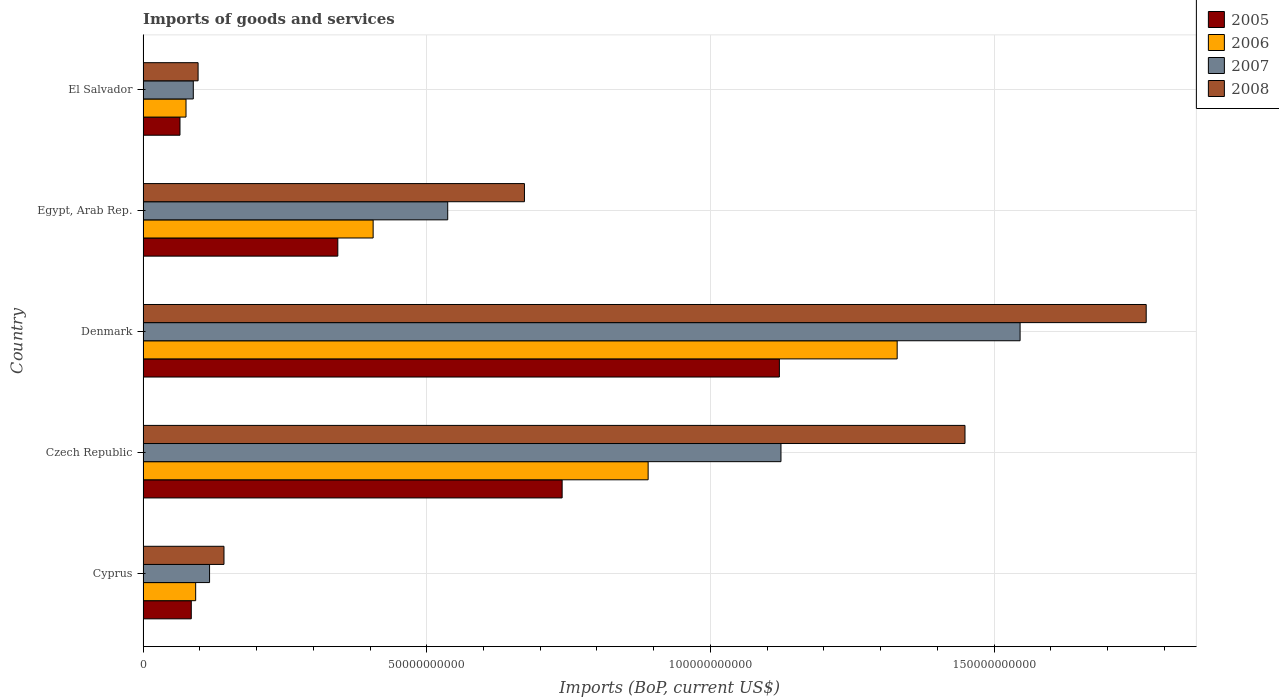How many different coloured bars are there?
Your answer should be compact. 4. How many groups of bars are there?
Your answer should be compact. 5. Are the number of bars on each tick of the Y-axis equal?
Offer a very short reply. Yes. How many bars are there on the 5th tick from the bottom?
Ensure brevity in your answer.  4. What is the label of the 1st group of bars from the top?
Keep it short and to the point. El Salvador. What is the amount spent on imports in 2007 in Egypt, Arab Rep.?
Keep it short and to the point. 5.37e+1. Across all countries, what is the maximum amount spent on imports in 2006?
Ensure brevity in your answer.  1.33e+11. Across all countries, what is the minimum amount spent on imports in 2008?
Give a very brief answer. 9.70e+09. In which country was the amount spent on imports in 2005 maximum?
Offer a very short reply. Denmark. In which country was the amount spent on imports in 2007 minimum?
Provide a succinct answer. El Salvador. What is the total amount spent on imports in 2007 in the graph?
Your response must be concise. 3.41e+11. What is the difference between the amount spent on imports in 2006 in Cyprus and that in Egypt, Arab Rep.?
Provide a succinct answer. -3.13e+1. What is the difference between the amount spent on imports in 2008 in Egypt, Arab Rep. and the amount spent on imports in 2007 in Czech Republic?
Offer a terse response. -4.52e+1. What is the average amount spent on imports in 2008 per country?
Offer a very short reply. 8.26e+1. What is the difference between the amount spent on imports in 2006 and amount spent on imports in 2005 in Egypt, Arab Rep.?
Your response must be concise. 6.23e+09. In how many countries, is the amount spent on imports in 2007 greater than 110000000000 US$?
Your answer should be compact. 2. What is the ratio of the amount spent on imports in 2006 in Czech Republic to that in Egypt, Arab Rep.?
Your answer should be compact. 2.2. Is the amount spent on imports in 2007 in Czech Republic less than that in Egypt, Arab Rep.?
Give a very brief answer. No. What is the difference between the highest and the second highest amount spent on imports in 2007?
Make the answer very short. 4.21e+1. What is the difference between the highest and the lowest amount spent on imports in 2007?
Your answer should be very brief. 1.46e+11. Is the sum of the amount spent on imports in 2005 in Cyprus and Czech Republic greater than the maximum amount spent on imports in 2007 across all countries?
Your answer should be very brief. No. What does the 2nd bar from the bottom in El Salvador represents?
Provide a succinct answer. 2006. Is it the case that in every country, the sum of the amount spent on imports in 2005 and amount spent on imports in 2008 is greater than the amount spent on imports in 2006?
Make the answer very short. Yes. How many bars are there?
Offer a very short reply. 20. Does the graph contain any zero values?
Keep it short and to the point. No. Does the graph contain grids?
Your answer should be very brief. Yes. Where does the legend appear in the graph?
Provide a succinct answer. Top right. What is the title of the graph?
Offer a very short reply. Imports of goods and services. What is the label or title of the X-axis?
Your answer should be very brief. Imports (BoP, current US$). What is the Imports (BoP, current US$) in 2005 in Cyprus?
Offer a terse response. 8.50e+09. What is the Imports (BoP, current US$) in 2006 in Cyprus?
Ensure brevity in your answer.  9.27e+09. What is the Imports (BoP, current US$) of 2007 in Cyprus?
Your answer should be compact. 1.17e+1. What is the Imports (BoP, current US$) of 2008 in Cyprus?
Provide a short and direct response. 1.43e+1. What is the Imports (BoP, current US$) in 2005 in Czech Republic?
Provide a short and direct response. 7.39e+1. What is the Imports (BoP, current US$) of 2006 in Czech Republic?
Give a very brief answer. 8.90e+1. What is the Imports (BoP, current US$) of 2007 in Czech Republic?
Ensure brevity in your answer.  1.12e+11. What is the Imports (BoP, current US$) of 2008 in Czech Republic?
Give a very brief answer. 1.45e+11. What is the Imports (BoP, current US$) in 2005 in Denmark?
Your answer should be very brief. 1.12e+11. What is the Imports (BoP, current US$) of 2006 in Denmark?
Offer a terse response. 1.33e+11. What is the Imports (BoP, current US$) in 2007 in Denmark?
Your answer should be compact. 1.55e+11. What is the Imports (BoP, current US$) of 2008 in Denmark?
Give a very brief answer. 1.77e+11. What is the Imports (BoP, current US$) in 2005 in Egypt, Arab Rep.?
Ensure brevity in your answer.  3.43e+1. What is the Imports (BoP, current US$) of 2006 in Egypt, Arab Rep.?
Provide a short and direct response. 4.06e+1. What is the Imports (BoP, current US$) of 2007 in Egypt, Arab Rep.?
Ensure brevity in your answer.  5.37e+1. What is the Imports (BoP, current US$) of 2008 in Egypt, Arab Rep.?
Keep it short and to the point. 6.72e+1. What is the Imports (BoP, current US$) of 2005 in El Salvador?
Your response must be concise. 6.51e+09. What is the Imports (BoP, current US$) of 2006 in El Salvador?
Make the answer very short. 7.57e+09. What is the Imports (BoP, current US$) of 2007 in El Salvador?
Your response must be concise. 8.86e+09. What is the Imports (BoP, current US$) of 2008 in El Salvador?
Offer a very short reply. 9.70e+09. Across all countries, what is the maximum Imports (BoP, current US$) in 2005?
Your answer should be very brief. 1.12e+11. Across all countries, what is the maximum Imports (BoP, current US$) of 2006?
Your response must be concise. 1.33e+11. Across all countries, what is the maximum Imports (BoP, current US$) in 2007?
Give a very brief answer. 1.55e+11. Across all countries, what is the maximum Imports (BoP, current US$) of 2008?
Keep it short and to the point. 1.77e+11. Across all countries, what is the minimum Imports (BoP, current US$) in 2005?
Your response must be concise. 6.51e+09. Across all countries, what is the minimum Imports (BoP, current US$) in 2006?
Offer a very short reply. 7.57e+09. Across all countries, what is the minimum Imports (BoP, current US$) of 2007?
Provide a short and direct response. 8.86e+09. Across all countries, what is the minimum Imports (BoP, current US$) of 2008?
Offer a terse response. 9.70e+09. What is the total Imports (BoP, current US$) in 2005 in the graph?
Give a very brief answer. 2.35e+11. What is the total Imports (BoP, current US$) in 2006 in the graph?
Offer a terse response. 2.79e+11. What is the total Imports (BoP, current US$) of 2007 in the graph?
Keep it short and to the point. 3.41e+11. What is the total Imports (BoP, current US$) in 2008 in the graph?
Offer a terse response. 4.13e+11. What is the difference between the Imports (BoP, current US$) of 2005 in Cyprus and that in Czech Republic?
Your response must be concise. -6.54e+1. What is the difference between the Imports (BoP, current US$) in 2006 in Cyprus and that in Czech Republic?
Offer a terse response. -7.97e+1. What is the difference between the Imports (BoP, current US$) of 2007 in Cyprus and that in Czech Republic?
Keep it short and to the point. -1.01e+11. What is the difference between the Imports (BoP, current US$) in 2008 in Cyprus and that in Czech Republic?
Keep it short and to the point. -1.31e+11. What is the difference between the Imports (BoP, current US$) in 2005 in Cyprus and that in Denmark?
Your response must be concise. -1.04e+11. What is the difference between the Imports (BoP, current US$) in 2006 in Cyprus and that in Denmark?
Ensure brevity in your answer.  -1.24e+11. What is the difference between the Imports (BoP, current US$) in 2007 in Cyprus and that in Denmark?
Your answer should be very brief. -1.43e+11. What is the difference between the Imports (BoP, current US$) in 2008 in Cyprus and that in Denmark?
Offer a very short reply. -1.63e+11. What is the difference between the Imports (BoP, current US$) of 2005 in Cyprus and that in Egypt, Arab Rep.?
Your answer should be very brief. -2.58e+1. What is the difference between the Imports (BoP, current US$) in 2006 in Cyprus and that in Egypt, Arab Rep.?
Your response must be concise. -3.13e+1. What is the difference between the Imports (BoP, current US$) in 2007 in Cyprus and that in Egypt, Arab Rep.?
Provide a short and direct response. -4.20e+1. What is the difference between the Imports (BoP, current US$) in 2008 in Cyprus and that in Egypt, Arab Rep.?
Provide a succinct answer. -5.30e+1. What is the difference between the Imports (BoP, current US$) in 2005 in Cyprus and that in El Salvador?
Provide a succinct answer. 1.99e+09. What is the difference between the Imports (BoP, current US$) in 2006 in Cyprus and that in El Salvador?
Your answer should be very brief. 1.70e+09. What is the difference between the Imports (BoP, current US$) of 2007 in Cyprus and that in El Salvador?
Offer a very short reply. 2.87e+09. What is the difference between the Imports (BoP, current US$) in 2008 in Cyprus and that in El Salvador?
Your answer should be compact. 4.56e+09. What is the difference between the Imports (BoP, current US$) of 2005 in Czech Republic and that in Denmark?
Your answer should be very brief. -3.83e+1. What is the difference between the Imports (BoP, current US$) in 2006 in Czech Republic and that in Denmark?
Your answer should be very brief. -4.39e+1. What is the difference between the Imports (BoP, current US$) in 2007 in Czech Republic and that in Denmark?
Offer a very short reply. -4.21e+1. What is the difference between the Imports (BoP, current US$) of 2008 in Czech Republic and that in Denmark?
Give a very brief answer. -3.19e+1. What is the difference between the Imports (BoP, current US$) in 2005 in Czech Republic and that in Egypt, Arab Rep.?
Make the answer very short. 3.95e+1. What is the difference between the Imports (BoP, current US$) in 2006 in Czech Republic and that in Egypt, Arab Rep.?
Ensure brevity in your answer.  4.85e+1. What is the difference between the Imports (BoP, current US$) of 2007 in Czech Republic and that in Egypt, Arab Rep.?
Offer a very short reply. 5.87e+1. What is the difference between the Imports (BoP, current US$) of 2008 in Czech Republic and that in Egypt, Arab Rep.?
Give a very brief answer. 7.76e+1. What is the difference between the Imports (BoP, current US$) in 2005 in Czech Republic and that in El Salvador?
Provide a short and direct response. 6.74e+1. What is the difference between the Imports (BoP, current US$) of 2006 in Czech Republic and that in El Salvador?
Your answer should be compact. 8.15e+1. What is the difference between the Imports (BoP, current US$) in 2007 in Czech Republic and that in El Salvador?
Offer a terse response. 1.04e+11. What is the difference between the Imports (BoP, current US$) in 2008 in Czech Republic and that in El Salvador?
Your answer should be very brief. 1.35e+11. What is the difference between the Imports (BoP, current US$) of 2005 in Denmark and that in Egypt, Arab Rep.?
Ensure brevity in your answer.  7.78e+1. What is the difference between the Imports (BoP, current US$) of 2006 in Denmark and that in Egypt, Arab Rep.?
Keep it short and to the point. 9.24e+1. What is the difference between the Imports (BoP, current US$) in 2007 in Denmark and that in Egypt, Arab Rep.?
Offer a terse response. 1.01e+11. What is the difference between the Imports (BoP, current US$) in 2008 in Denmark and that in Egypt, Arab Rep.?
Provide a succinct answer. 1.10e+11. What is the difference between the Imports (BoP, current US$) of 2005 in Denmark and that in El Salvador?
Offer a terse response. 1.06e+11. What is the difference between the Imports (BoP, current US$) of 2006 in Denmark and that in El Salvador?
Offer a terse response. 1.25e+11. What is the difference between the Imports (BoP, current US$) in 2007 in Denmark and that in El Salvador?
Your answer should be compact. 1.46e+11. What is the difference between the Imports (BoP, current US$) of 2008 in Denmark and that in El Salvador?
Offer a terse response. 1.67e+11. What is the difference between the Imports (BoP, current US$) in 2005 in Egypt, Arab Rep. and that in El Salvador?
Make the answer very short. 2.78e+1. What is the difference between the Imports (BoP, current US$) in 2006 in Egypt, Arab Rep. and that in El Salvador?
Provide a short and direct response. 3.30e+1. What is the difference between the Imports (BoP, current US$) in 2007 in Egypt, Arab Rep. and that in El Salvador?
Keep it short and to the point. 4.48e+1. What is the difference between the Imports (BoP, current US$) of 2008 in Egypt, Arab Rep. and that in El Salvador?
Give a very brief answer. 5.75e+1. What is the difference between the Imports (BoP, current US$) of 2005 in Cyprus and the Imports (BoP, current US$) of 2006 in Czech Republic?
Your response must be concise. -8.05e+1. What is the difference between the Imports (BoP, current US$) in 2005 in Cyprus and the Imports (BoP, current US$) in 2007 in Czech Republic?
Make the answer very short. -1.04e+11. What is the difference between the Imports (BoP, current US$) in 2005 in Cyprus and the Imports (BoP, current US$) in 2008 in Czech Republic?
Your response must be concise. -1.36e+11. What is the difference between the Imports (BoP, current US$) in 2006 in Cyprus and the Imports (BoP, current US$) in 2007 in Czech Republic?
Your answer should be very brief. -1.03e+11. What is the difference between the Imports (BoP, current US$) in 2006 in Cyprus and the Imports (BoP, current US$) in 2008 in Czech Republic?
Offer a terse response. -1.36e+11. What is the difference between the Imports (BoP, current US$) of 2007 in Cyprus and the Imports (BoP, current US$) of 2008 in Czech Republic?
Keep it short and to the point. -1.33e+11. What is the difference between the Imports (BoP, current US$) in 2005 in Cyprus and the Imports (BoP, current US$) in 2006 in Denmark?
Make the answer very short. -1.24e+11. What is the difference between the Imports (BoP, current US$) in 2005 in Cyprus and the Imports (BoP, current US$) in 2007 in Denmark?
Ensure brevity in your answer.  -1.46e+11. What is the difference between the Imports (BoP, current US$) in 2005 in Cyprus and the Imports (BoP, current US$) in 2008 in Denmark?
Offer a very short reply. -1.68e+11. What is the difference between the Imports (BoP, current US$) of 2006 in Cyprus and the Imports (BoP, current US$) of 2007 in Denmark?
Ensure brevity in your answer.  -1.45e+11. What is the difference between the Imports (BoP, current US$) of 2006 in Cyprus and the Imports (BoP, current US$) of 2008 in Denmark?
Give a very brief answer. -1.68e+11. What is the difference between the Imports (BoP, current US$) in 2007 in Cyprus and the Imports (BoP, current US$) in 2008 in Denmark?
Keep it short and to the point. -1.65e+11. What is the difference between the Imports (BoP, current US$) of 2005 in Cyprus and the Imports (BoP, current US$) of 2006 in Egypt, Arab Rep.?
Offer a very short reply. -3.21e+1. What is the difference between the Imports (BoP, current US$) in 2005 in Cyprus and the Imports (BoP, current US$) in 2007 in Egypt, Arab Rep.?
Offer a very short reply. -4.52e+1. What is the difference between the Imports (BoP, current US$) in 2005 in Cyprus and the Imports (BoP, current US$) in 2008 in Egypt, Arab Rep.?
Keep it short and to the point. -5.87e+1. What is the difference between the Imports (BoP, current US$) of 2006 in Cyprus and the Imports (BoP, current US$) of 2007 in Egypt, Arab Rep.?
Ensure brevity in your answer.  -4.44e+1. What is the difference between the Imports (BoP, current US$) of 2006 in Cyprus and the Imports (BoP, current US$) of 2008 in Egypt, Arab Rep.?
Your answer should be very brief. -5.79e+1. What is the difference between the Imports (BoP, current US$) in 2007 in Cyprus and the Imports (BoP, current US$) in 2008 in Egypt, Arab Rep.?
Your answer should be very brief. -5.55e+1. What is the difference between the Imports (BoP, current US$) in 2005 in Cyprus and the Imports (BoP, current US$) in 2006 in El Salvador?
Make the answer very short. 9.27e+08. What is the difference between the Imports (BoP, current US$) in 2005 in Cyprus and the Imports (BoP, current US$) in 2007 in El Salvador?
Give a very brief answer. -3.57e+08. What is the difference between the Imports (BoP, current US$) of 2005 in Cyprus and the Imports (BoP, current US$) of 2008 in El Salvador?
Provide a succinct answer. -1.20e+09. What is the difference between the Imports (BoP, current US$) of 2006 in Cyprus and the Imports (BoP, current US$) of 2007 in El Salvador?
Offer a very short reply. 4.18e+08. What is the difference between the Imports (BoP, current US$) of 2006 in Cyprus and the Imports (BoP, current US$) of 2008 in El Salvador?
Provide a short and direct response. -4.26e+08. What is the difference between the Imports (BoP, current US$) in 2007 in Cyprus and the Imports (BoP, current US$) in 2008 in El Salvador?
Offer a terse response. 2.02e+09. What is the difference between the Imports (BoP, current US$) in 2005 in Czech Republic and the Imports (BoP, current US$) in 2006 in Denmark?
Provide a short and direct response. -5.91e+1. What is the difference between the Imports (BoP, current US$) in 2005 in Czech Republic and the Imports (BoP, current US$) in 2007 in Denmark?
Ensure brevity in your answer.  -8.07e+1. What is the difference between the Imports (BoP, current US$) of 2005 in Czech Republic and the Imports (BoP, current US$) of 2008 in Denmark?
Offer a terse response. -1.03e+11. What is the difference between the Imports (BoP, current US$) in 2006 in Czech Republic and the Imports (BoP, current US$) in 2007 in Denmark?
Offer a very short reply. -6.56e+1. What is the difference between the Imports (BoP, current US$) in 2006 in Czech Republic and the Imports (BoP, current US$) in 2008 in Denmark?
Your answer should be very brief. -8.78e+1. What is the difference between the Imports (BoP, current US$) in 2007 in Czech Republic and the Imports (BoP, current US$) in 2008 in Denmark?
Give a very brief answer. -6.44e+1. What is the difference between the Imports (BoP, current US$) in 2005 in Czech Republic and the Imports (BoP, current US$) in 2006 in Egypt, Arab Rep.?
Provide a short and direct response. 3.33e+1. What is the difference between the Imports (BoP, current US$) in 2005 in Czech Republic and the Imports (BoP, current US$) in 2007 in Egypt, Arab Rep.?
Ensure brevity in your answer.  2.02e+1. What is the difference between the Imports (BoP, current US$) of 2005 in Czech Republic and the Imports (BoP, current US$) of 2008 in Egypt, Arab Rep.?
Provide a succinct answer. 6.64e+09. What is the difference between the Imports (BoP, current US$) in 2006 in Czech Republic and the Imports (BoP, current US$) in 2007 in Egypt, Arab Rep.?
Your answer should be very brief. 3.53e+1. What is the difference between the Imports (BoP, current US$) of 2006 in Czech Republic and the Imports (BoP, current US$) of 2008 in Egypt, Arab Rep.?
Make the answer very short. 2.18e+1. What is the difference between the Imports (BoP, current US$) of 2007 in Czech Republic and the Imports (BoP, current US$) of 2008 in Egypt, Arab Rep.?
Provide a succinct answer. 4.52e+1. What is the difference between the Imports (BoP, current US$) in 2005 in Czech Republic and the Imports (BoP, current US$) in 2006 in El Salvador?
Provide a short and direct response. 6.63e+1. What is the difference between the Imports (BoP, current US$) in 2005 in Czech Republic and the Imports (BoP, current US$) in 2007 in El Salvador?
Your response must be concise. 6.50e+1. What is the difference between the Imports (BoP, current US$) in 2005 in Czech Republic and the Imports (BoP, current US$) in 2008 in El Salvador?
Keep it short and to the point. 6.42e+1. What is the difference between the Imports (BoP, current US$) of 2006 in Czech Republic and the Imports (BoP, current US$) of 2007 in El Salvador?
Your answer should be compact. 8.02e+1. What is the difference between the Imports (BoP, current US$) in 2006 in Czech Republic and the Imports (BoP, current US$) in 2008 in El Salvador?
Offer a very short reply. 7.93e+1. What is the difference between the Imports (BoP, current US$) of 2007 in Czech Republic and the Imports (BoP, current US$) of 2008 in El Salvador?
Give a very brief answer. 1.03e+11. What is the difference between the Imports (BoP, current US$) of 2005 in Denmark and the Imports (BoP, current US$) of 2006 in Egypt, Arab Rep.?
Your response must be concise. 7.16e+1. What is the difference between the Imports (BoP, current US$) of 2005 in Denmark and the Imports (BoP, current US$) of 2007 in Egypt, Arab Rep.?
Offer a terse response. 5.85e+1. What is the difference between the Imports (BoP, current US$) of 2005 in Denmark and the Imports (BoP, current US$) of 2008 in Egypt, Arab Rep.?
Your answer should be very brief. 4.49e+1. What is the difference between the Imports (BoP, current US$) of 2006 in Denmark and the Imports (BoP, current US$) of 2007 in Egypt, Arab Rep.?
Offer a very short reply. 7.92e+1. What is the difference between the Imports (BoP, current US$) of 2006 in Denmark and the Imports (BoP, current US$) of 2008 in Egypt, Arab Rep.?
Your response must be concise. 6.57e+1. What is the difference between the Imports (BoP, current US$) of 2007 in Denmark and the Imports (BoP, current US$) of 2008 in Egypt, Arab Rep.?
Your answer should be compact. 8.74e+1. What is the difference between the Imports (BoP, current US$) in 2005 in Denmark and the Imports (BoP, current US$) in 2006 in El Salvador?
Provide a short and direct response. 1.05e+11. What is the difference between the Imports (BoP, current US$) in 2005 in Denmark and the Imports (BoP, current US$) in 2007 in El Salvador?
Provide a succinct answer. 1.03e+11. What is the difference between the Imports (BoP, current US$) of 2005 in Denmark and the Imports (BoP, current US$) of 2008 in El Salvador?
Provide a succinct answer. 1.02e+11. What is the difference between the Imports (BoP, current US$) of 2006 in Denmark and the Imports (BoP, current US$) of 2007 in El Salvador?
Offer a terse response. 1.24e+11. What is the difference between the Imports (BoP, current US$) in 2006 in Denmark and the Imports (BoP, current US$) in 2008 in El Salvador?
Make the answer very short. 1.23e+11. What is the difference between the Imports (BoP, current US$) of 2007 in Denmark and the Imports (BoP, current US$) of 2008 in El Salvador?
Keep it short and to the point. 1.45e+11. What is the difference between the Imports (BoP, current US$) of 2005 in Egypt, Arab Rep. and the Imports (BoP, current US$) of 2006 in El Salvador?
Provide a short and direct response. 2.68e+1. What is the difference between the Imports (BoP, current US$) in 2005 in Egypt, Arab Rep. and the Imports (BoP, current US$) in 2007 in El Salvador?
Make the answer very short. 2.55e+1. What is the difference between the Imports (BoP, current US$) in 2005 in Egypt, Arab Rep. and the Imports (BoP, current US$) in 2008 in El Salvador?
Offer a terse response. 2.46e+1. What is the difference between the Imports (BoP, current US$) of 2006 in Egypt, Arab Rep. and the Imports (BoP, current US$) of 2007 in El Salvador?
Provide a succinct answer. 3.17e+1. What is the difference between the Imports (BoP, current US$) in 2006 in Egypt, Arab Rep. and the Imports (BoP, current US$) in 2008 in El Salvador?
Ensure brevity in your answer.  3.09e+1. What is the difference between the Imports (BoP, current US$) in 2007 in Egypt, Arab Rep. and the Imports (BoP, current US$) in 2008 in El Salvador?
Make the answer very short. 4.40e+1. What is the average Imports (BoP, current US$) of 2005 per country?
Give a very brief answer. 4.71e+1. What is the average Imports (BoP, current US$) of 2006 per country?
Keep it short and to the point. 5.59e+1. What is the average Imports (BoP, current US$) in 2007 per country?
Offer a very short reply. 6.83e+1. What is the average Imports (BoP, current US$) in 2008 per country?
Keep it short and to the point. 8.26e+1. What is the difference between the Imports (BoP, current US$) of 2005 and Imports (BoP, current US$) of 2006 in Cyprus?
Give a very brief answer. -7.76e+08. What is the difference between the Imports (BoP, current US$) in 2005 and Imports (BoP, current US$) in 2007 in Cyprus?
Make the answer very short. -3.22e+09. What is the difference between the Imports (BoP, current US$) of 2005 and Imports (BoP, current US$) of 2008 in Cyprus?
Offer a very short reply. -5.77e+09. What is the difference between the Imports (BoP, current US$) of 2006 and Imports (BoP, current US$) of 2007 in Cyprus?
Give a very brief answer. -2.45e+09. What is the difference between the Imports (BoP, current US$) of 2006 and Imports (BoP, current US$) of 2008 in Cyprus?
Make the answer very short. -4.99e+09. What is the difference between the Imports (BoP, current US$) in 2007 and Imports (BoP, current US$) in 2008 in Cyprus?
Your response must be concise. -2.54e+09. What is the difference between the Imports (BoP, current US$) in 2005 and Imports (BoP, current US$) in 2006 in Czech Republic?
Ensure brevity in your answer.  -1.52e+1. What is the difference between the Imports (BoP, current US$) of 2005 and Imports (BoP, current US$) of 2007 in Czech Republic?
Make the answer very short. -3.86e+1. What is the difference between the Imports (BoP, current US$) of 2005 and Imports (BoP, current US$) of 2008 in Czech Republic?
Your response must be concise. -7.10e+1. What is the difference between the Imports (BoP, current US$) of 2006 and Imports (BoP, current US$) of 2007 in Czech Republic?
Your answer should be compact. -2.34e+1. What is the difference between the Imports (BoP, current US$) in 2006 and Imports (BoP, current US$) in 2008 in Czech Republic?
Keep it short and to the point. -5.58e+1. What is the difference between the Imports (BoP, current US$) of 2007 and Imports (BoP, current US$) of 2008 in Czech Republic?
Your answer should be compact. -3.24e+1. What is the difference between the Imports (BoP, current US$) in 2005 and Imports (BoP, current US$) in 2006 in Denmark?
Your answer should be very brief. -2.08e+1. What is the difference between the Imports (BoP, current US$) of 2005 and Imports (BoP, current US$) of 2007 in Denmark?
Your answer should be compact. -4.24e+1. What is the difference between the Imports (BoP, current US$) in 2005 and Imports (BoP, current US$) in 2008 in Denmark?
Provide a short and direct response. -6.47e+1. What is the difference between the Imports (BoP, current US$) in 2006 and Imports (BoP, current US$) in 2007 in Denmark?
Make the answer very short. -2.17e+1. What is the difference between the Imports (BoP, current US$) in 2006 and Imports (BoP, current US$) in 2008 in Denmark?
Your answer should be very brief. -4.39e+1. What is the difference between the Imports (BoP, current US$) of 2007 and Imports (BoP, current US$) of 2008 in Denmark?
Give a very brief answer. -2.22e+1. What is the difference between the Imports (BoP, current US$) in 2005 and Imports (BoP, current US$) in 2006 in Egypt, Arab Rep.?
Keep it short and to the point. -6.23e+09. What is the difference between the Imports (BoP, current US$) in 2005 and Imports (BoP, current US$) in 2007 in Egypt, Arab Rep.?
Your response must be concise. -1.94e+1. What is the difference between the Imports (BoP, current US$) of 2005 and Imports (BoP, current US$) of 2008 in Egypt, Arab Rep.?
Offer a terse response. -3.29e+1. What is the difference between the Imports (BoP, current US$) of 2006 and Imports (BoP, current US$) of 2007 in Egypt, Arab Rep.?
Your answer should be very brief. -1.31e+1. What is the difference between the Imports (BoP, current US$) in 2006 and Imports (BoP, current US$) in 2008 in Egypt, Arab Rep.?
Provide a succinct answer. -2.67e+1. What is the difference between the Imports (BoP, current US$) in 2007 and Imports (BoP, current US$) in 2008 in Egypt, Arab Rep.?
Ensure brevity in your answer.  -1.35e+1. What is the difference between the Imports (BoP, current US$) in 2005 and Imports (BoP, current US$) in 2006 in El Salvador?
Give a very brief answer. -1.06e+09. What is the difference between the Imports (BoP, current US$) of 2005 and Imports (BoP, current US$) of 2007 in El Salvador?
Make the answer very short. -2.35e+09. What is the difference between the Imports (BoP, current US$) in 2005 and Imports (BoP, current US$) in 2008 in El Salvador?
Your response must be concise. -3.19e+09. What is the difference between the Imports (BoP, current US$) in 2006 and Imports (BoP, current US$) in 2007 in El Salvador?
Your response must be concise. -1.28e+09. What is the difference between the Imports (BoP, current US$) in 2006 and Imports (BoP, current US$) in 2008 in El Salvador?
Offer a terse response. -2.13e+09. What is the difference between the Imports (BoP, current US$) in 2007 and Imports (BoP, current US$) in 2008 in El Salvador?
Provide a short and direct response. -8.44e+08. What is the ratio of the Imports (BoP, current US$) of 2005 in Cyprus to that in Czech Republic?
Your response must be concise. 0.12. What is the ratio of the Imports (BoP, current US$) in 2006 in Cyprus to that in Czech Republic?
Your answer should be compact. 0.1. What is the ratio of the Imports (BoP, current US$) of 2007 in Cyprus to that in Czech Republic?
Ensure brevity in your answer.  0.1. What is the ratio of the Imports (BoP, current US$) in 2008 in Cyprus to that in Czech Republic?
Provide a short and direct response. 0.1. What is the ratio of the Imports (BoP, current US$) in 2005 in Cyprus to that in Denmark?
Your response must be concise. 0.08. What is the ratio of the Imports (BoP, current US$) in 2006 in Cyprus to that in Denmark?
Ensure brevity in your answer.  0.07. What is the ratio of the Imports (BoP, current US$) of 2007 in Cyprus to that in Denmark?
Offer a terse response. 0.08. What is the ratio of the Imports (BoP, current US$) in 2008 in Cyprus to that in Denmark?
Make the answer very short. 0.08. What is the ratio of the Imports (BoP, current US$) in 2005 in Cyprus to that in Egypt, Arab Rep.?
Ensure brevity in your answer.  0.25. What is the ratio of the Imports (BoP, current US$) in 2006 in Cyprus to that in Egypt, Arab Rep.?
Give a very brief answer. 0.23. What is the ratio of the Imports (BoP, current US$) of 2007 in Cyprus to that in Egypt, Arab Rep.?
Provide a short and direct response. 0.22. What is the ratio of the Imports (BoP, current US$) in 2008 in Cyprus to that in Egypt, Arab Rep.?
Your response must be concise. 0.21. What is the ratio of the Imports (BoP, current US$) in 2005 in Cyprus to that in El Salvador?
Provide a short and direct response. 1.31. What is the ratio of the Imports (BoP, current US$) in 2006 in Cyprus to that in El Salvador?
Provide a succinct answer. 1.22. What is the ratio of the Imports (BoP, current US$) in 2007 in Cyprus to that in El Salvador?
Your answer should be compact. 1.32. What is the ratio of the Imports (BoP, current US$) in 2008 in Cyprus to that in El Salvador?
Provide a succinct answer. 1.47. What is the ratio of the Imports (BoP, current US$) in 2005 in Czech Republic to that in Denmark?
Provide a succinct answer. 0.66. What is the ratio of the Imports (BoP, current US$) in 2006 in Czech Republic to that in Denmark?
Ensure brevity in your answer.  0.67. What is the ratio of the Imports (BoP, current US$) of 2007 in Czech Republic to that in Denmark?
Your response must be concise. 0.73. What is the ratio of the Imports (BoP, current US$) of 2008 in Czech Republic to that in Denmark?
Your answer should be very brief. 0.82. What is the ratio of the Imports (BoP, current US$) of 2005 in Czech Republic to that in Egypt, Arab Rep.?
Offer a terse response. 2.15. What is the ratio of the Imports (BoP, current US$) in 2006 in Czech Republic to that in Egypt, Arab Rep.?
Your answer should be very brief. 2.2. What is the ratio of the Imports (BoP, current US$) in 2007 in Czech Republic to that in Egypt, Arab Rep.?
Offer a very short reply. 2.09. What is the ratio of the Imports (BoP, current US$) of 2008 in Czech Republic to that in Egypt, Arab Rep.?
Offer a very short reply. 2.16. What is the ratio of the Imports (BoP, current US$) in 2005 in Czech Republic to that in El Salvador?
Offer a terse response. 11.35. What is the ratio of the Imports (BoP, current US$) in 2006 in Czech Republic to that in El Salvador?
Your response must be concise. 11.76. What is the ratio of the Imports (BoP, current US$) of 2007 in Czech Republic to that in El Salvador?
Your answer should be very brief. 12.7. What is the ratio of the Imports (BoP, current US$) of 2008 in Czech Republic to that in El Salvador?
Your response must be concise. 14.94. What is the ratio of the Imports (BoP, current US$) in 2005 in Denmark to that in Egypt, Arab Rep.?
Provide a succinct answer. 3.27. What is the ratio of the Imports (BoP, current US$) in 2006 in Denmark to that in Egypt, Arab Rep.?
Offer a very short reply. 3.28. What is the ratio of the Imports (BoP, current US$) in 2007 in Denmark to that in Egypt, Arab Rep.?
Offer a terse response. 2.88. What is the ratio of the Imports (BoP, current US$) in 2008 in Denmark to that in Egypt, Arab Rep.?
Provide a short and direct response. 2.63. What is the ratio of the Imports (BoP, current US$) in 2005 in Denmark to that in El Salvador?
Give a very brief answer. 17.23. What is the ratio of the Imports (BoP, current US$) in 2006 in Denmark to that in El Salvador?
Offer a terse response. 17.56. What is the ratio of the Imports (BoP, current US$) in 2007 in Denmark to that in El Salvador?
Your answer should be compact. 17.46. What is the ratio of the Imports (BoP, current US$) of 2008 in Denmark to that in El Salvador?
Provide a short and direct response. 18.23. What is the ratio of the Imports (BoP, current US$) in 2005 in Egypt, Arab Rep. to that in El Salvador?
Provide a short and direct response. 5.27. What is the ratio of the Imports (BoP, current US$) of 2006 in Egypt, Arab Rep. to that in El Salvador?
Give a very brief answer. 5.36. What is the ratio of the Imports (BoP, current US$) of 2007 in Egypt, Arab Rep. to that in El Salvador?
Your answer should be compact. 6.06. What is the ratio of the Imports (BoP, current US$) in 2008 in Egypt, Arab Rep. to that in El Salvador?
Keep it short and to the point. 6.93. What is the difference between the highest and the second highest Imports (BoP, current US$) of 2005?
Ensure brevity in your answer.  3.83e+1. What is the difference between the highest and the second highest Imports (BoP, current US$) of 2006?
Give a very brief answer. 4.39e+1. What is the difference between the highest and the second highest Imports (BoP, current US$) of 2007?
Make the answer very short. 4.21e+1. What is the difference between the highest and the second highest Imports (BoP, current US$) in 2008?
Your answer should be compact. 3.19e+1. What is the difference between the highest and the lowest Imports (BoP, current US$) of 2005?
Give a very brief answer. 1.06e+11. What is the difference between the highest and the lowest Imports (BoP, current US$) of 2006?
Provide a short and direct response. 1.25e+11. What is the difference between the highest and the lowest Imports (BoP, current US$) in 2007?
Provide a succinct answer. 1.46e+11. What is the difference between the highest and the lowest Imports (BoP, current US$) in 2008?
Your answer should be very brief. 1.67e+11. 